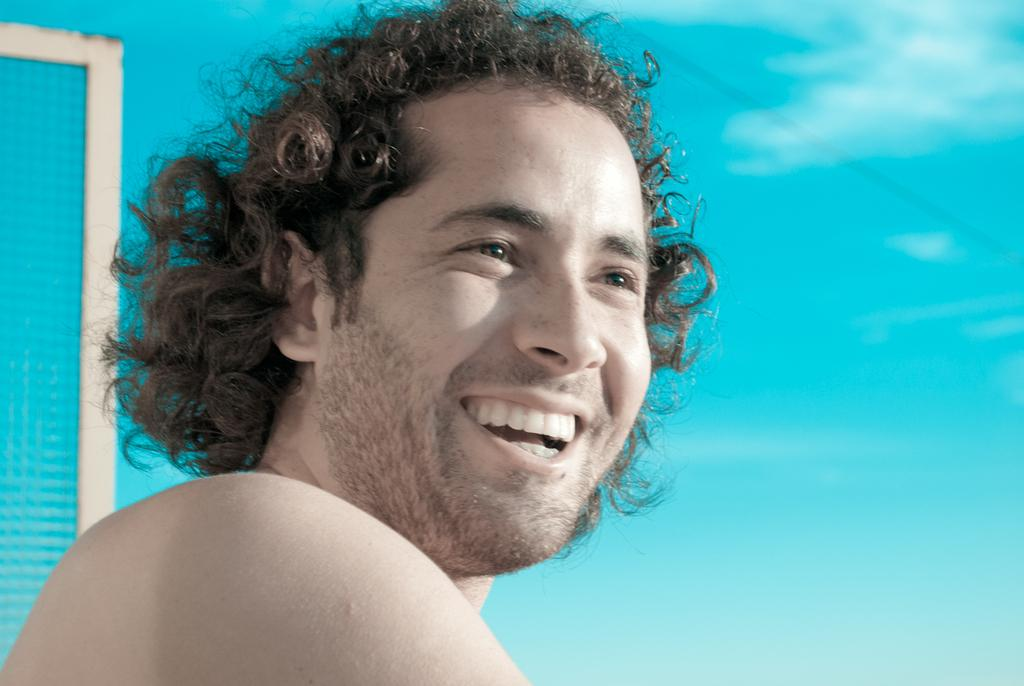Who is present in the image? There is a man in the image. What is the man's facial expression? The man is smiling. What can be seen in the background of the image? There is a sky visible in the image. How many aunts are present in the image? There are no aunts present in the image; it features a man. What type of spiders can be seen in the image? There are no spiders present in the image. 